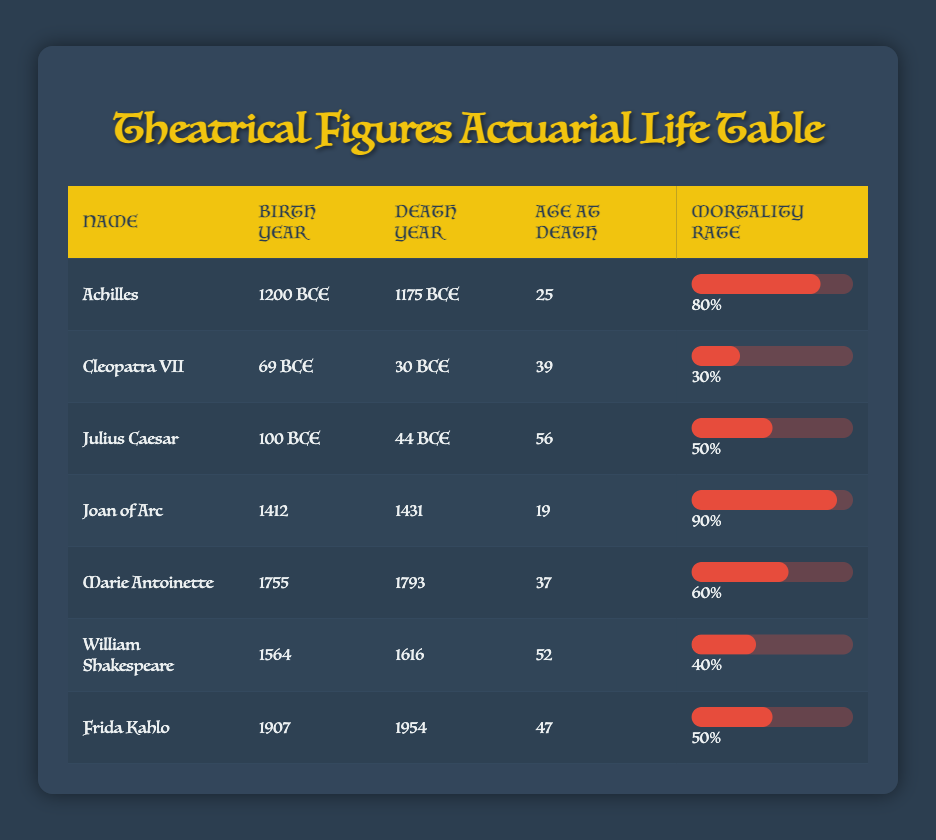What is the age at death of Cleopatra VII? According to the table, the entry for Cleopatra VII indicates her age at death is 39.
Answer: 39 What is the mortality rate of Julius Caesar? The table lists Julius Caesar's mortality rate as 0.5, which corresponds to 50%.
Answer: 50% Who lived longer, Marie Antoinette or Frida Kahlo? Marie Antoinette died at 37, while Frida Kahlo died at 47. Therefore, Frida Kahlo lived longer.
Answer: Frida Kahlo What is the average age at death for the figures in the table? The ages at death from the table are 25, 39, 56, 19, 37, 52, and 47. Adding these gives 25 + 39 + 56 + 19 + 37 + 52 + 47 = 275. There are 7 figures, so the average is 275 / 7 = 39.29, which rounds to approximately 39.3.
Answer: Approximately 39.3 Did Joan of Arc have a lower mortality rate than Cleopatra VII? Joan of Arc's mortality rate is 0.9 (90%) and Cleopatra VII's is 0.3 (30%). Since 90% is higher than 30%, the statement is false.
Answer: No 